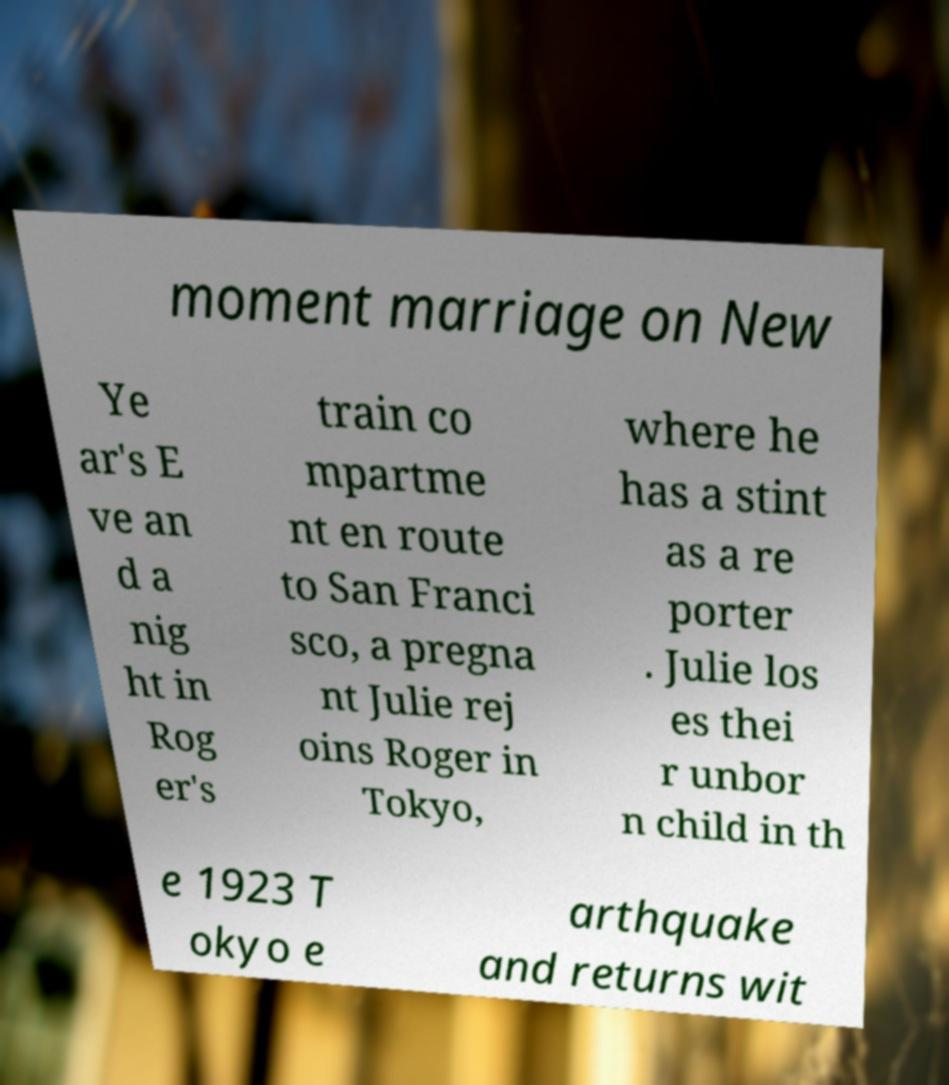There's text embedded in this image that I need extracted. Can you transcribe it verbatim? moment marriage on New Ye ar's E ve an d a nig ht in Rog er's train co mpartme nt en route to San Franci sco, a pregna nt Julie rej oins Roger in Tokyo, where he has a stint as a re porter . Julie los es thei r unbor n child in th e 1923 T okyo e arthquake and returns wit 